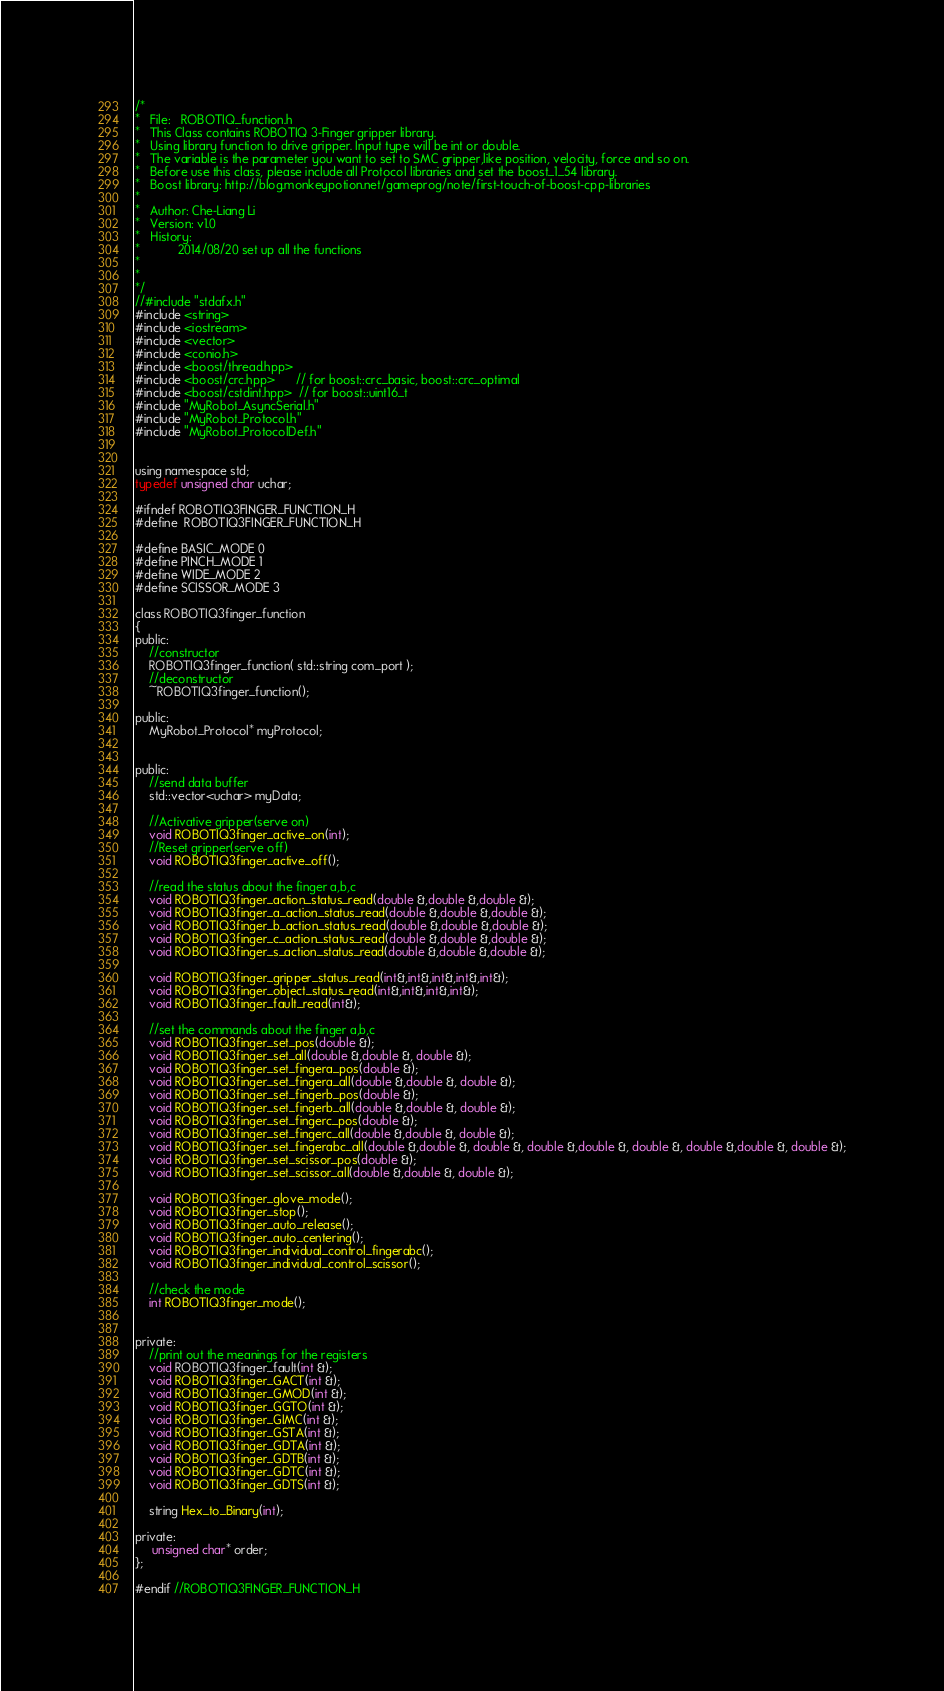<code> <loc_0><loc_0><loc_500><loc_500><_C_>/*
*   File:   ROBOTIQ_function.h
*	This Class contains ROBOTIQ 3-Finger gripper library.
*   Using library function to drive gripper. Input type will be int or double.
*	The variable is the parameter you want to set to SMC gripper,like position, velocity, force and so on.
*	Before use this class, please include all Protocol libraries and set the boost_1_54 library.
*   Boost library: http://blog.monkeypotion.net/gameprog/note/first-touch-of-boost-cpp-libraries
*
*	Author: Che-Liang Li
*	Version: v1.0
*	History:
*			2014/08/20 set up all the functions      
*													    
*
*/
//#include "stdafx.h"
#include <string>
#include <iostream>
#include <vector>
#include <conio.h>
#include <boost/thread.hpp>
#include <boost/crc.hpp>      // for boost::crc_basic, boost::crc_optimal
#include <boost/cstdint.hpp>  // for boost::uint16_t
#include "MyRobot_AsyncSerial.h"
#include "MyRobot_Protocol.h"
#include "MyRobot_ProtocolDef.h"


using namespace std;
typedef unsigned char uchar;

#ifndef ROBOTIQ3FINGER_FUNCTION_H   
#define	ROBOTIQ3FINGER_FUNCTION_H

#define BASIC_MODE 0
#define PINCH_MODE 1
#define WIDE_MODE 2
#define SCISSOR_MODE 3

class ROBOTIQ3finger_function
{ 
public:	
    //constructor
	ROBOTIQ3finger_function( std::string com_port );
	//deconstructor
	~ROBOTIQ3finger_function();

public:
	MyRobot_Protocol* myProtocol;
	

public:
	//send data buffer
	std::vector<uchar> myData;

    //Activative gripper(serve on)
	void ROBOTIQ3finger_active_on(int);
	//Reset gripper(serve off)
	void ROBOTIQ3finger_active_off();

	//read the status about the finger a,b,c
	void ROBOTIQ3finger_action_status_read(double &,double &,double &);
	void ROBOTIQ3finger_a_action_status_read(double &,double &,double &);
	void ROBOTIQ3finger_b_action_status_read(double &,double &,double &);
	void ROBOTIQ3finger_c_action_status_read(double &,double &,double &);
	void ROBOTIQ3finger_s_action_status_read(double &,double &,double &);
	
	void ROBOTIQ3finger_gripper_status_read(int&,int&,int&,int&,int&);
	void ROBOTIQ3finger_object_status_read(int&,int&,int&,int&);
	void ROBOTIQ3finger_fault_read(int&);
	
	//set the commands about the finger a,b,c
	void ROBOTIQ3finger_set_pos(double &);
	void ROBOTIQ3finger_set_all(double &,double &, double &);
	void ROBOTIQ3finger_set_fingera_pos(double &);
	void ROBOTIQ3finger_set_fingera_all(double &,double &, double &);
	void ROBOTIQ3finger_set_fingerb_pos(double &);
	void ROBOTIQ3finger_set_fingerb_all(double &,double &, double &);
	void ROBOTIQ3finger_set_fingerc_pos(double &);
	void ROBOTIQ3finger_set_fingerc_all(double &,double &, double &);
	void ROBOTIQ3finger_set_fingerabc_all(double &,double &, double &, double &,double &, double &, double &,double &, double &);
	void ROBOTIQ3finger_set_scissor_pos(double &);
	void ROBOTIQ3finger_set_scissor_all(double &,double &, double &);
	
	void ROBOTIQ3finger_glove_mode();
	void ROBOTIQ3finger_stop();
	void ROBOTIQ3finger_auto_release();
	void ROBOTIQ3finger_auto_centering();
	void ROBOTIQ3finger_individual_control_fingerabc();
	void ROBOTIQ3finger_individual_control_scissor();
	
	//check the mode
	int ROBOTIQ3finger_mode();


private:
	//print out the meanings for the registers
    void ROBOTIQ3finger_fault(int &);
	void ROBOTIQ3finger_GACT(int &);
	void ROBOTIQ3finger_GMOD(int &);
	void ROBOTIQ3finger_GGTO(int &);
	void ROBOTIQ3finger_GIMC(int &);
	void ROBOTIQ3finger_GSTA(int &);
	void ROBOTIQ3finger_GDTA(int &);
	void ROBOTIQ3finger_GDTB(int &);
	void ROBOTIQ3finger_GDTC(int &);
	void ROBOTIQ3finger_GDTS(int &);

	string Hex_to_Binary(int);
	
private:
     unsigned char* order;
};

#endif //ROBOTIQ3FINGER_FUNCTION_H  

</code> 